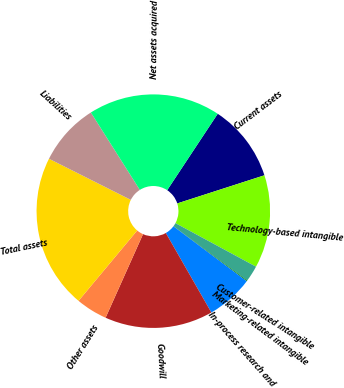Convert chart. <chart><loc_0><loc_0><loc_500><loc_500><pie_chart><fcel>Current assets<fcel>Technology-based intangible<fcel>Customer-related intangible<fcel>Marketing-related intangible<fcel>In-process research and<fcel>Goodwill<fcel>Other assets<fcel>Total assets<fcel>Liabilities<fcel>Net assets acquired<nl><fcel>10.73%<fcel>12.86%<fcel>2.24%<fcel>0.11%<fcel>6.48%<fcel>14.98%<fcel>4.36%<fcel>21.35%<fcel>8.61%<fcel>18.28%<nl></chart> 